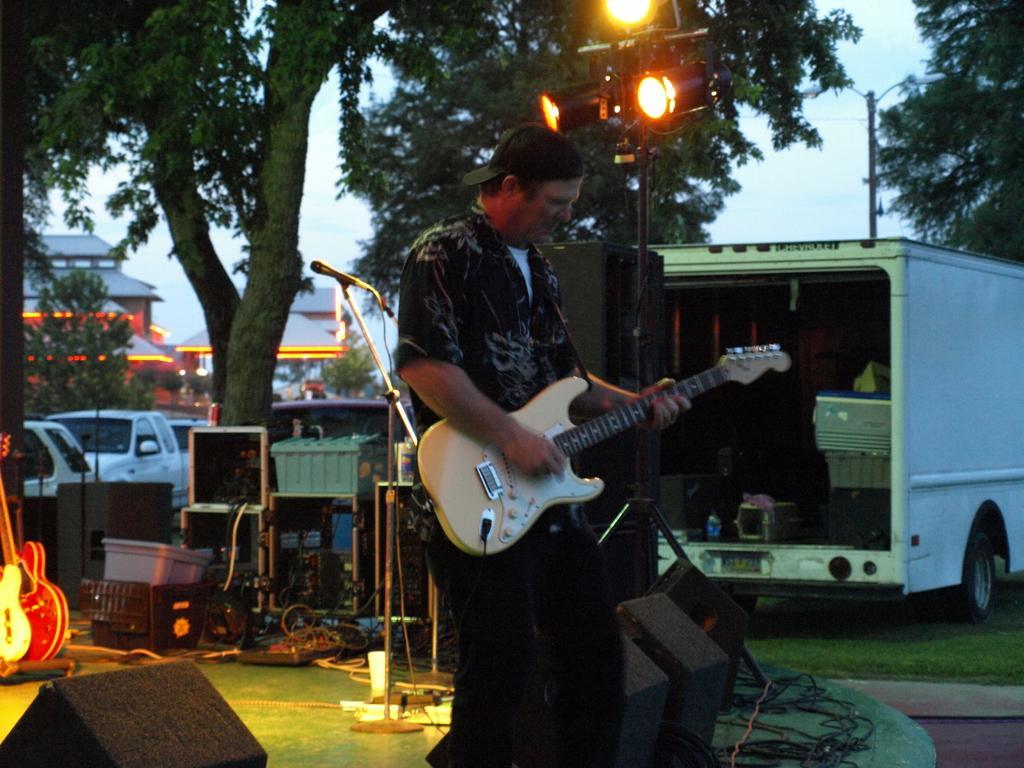Could you give a brief overview of what you see in this image? The image is outside of the city. In the image there is a man holding a guitar and playing it, on right side there is a van inside the van we can see a bottle,speakers and a cloth on table. On left side we can see a guitar,basket,wires,microphone. In background there are some trees,lights,electric pole,street light and sky is on top at bottom there is a grass. 